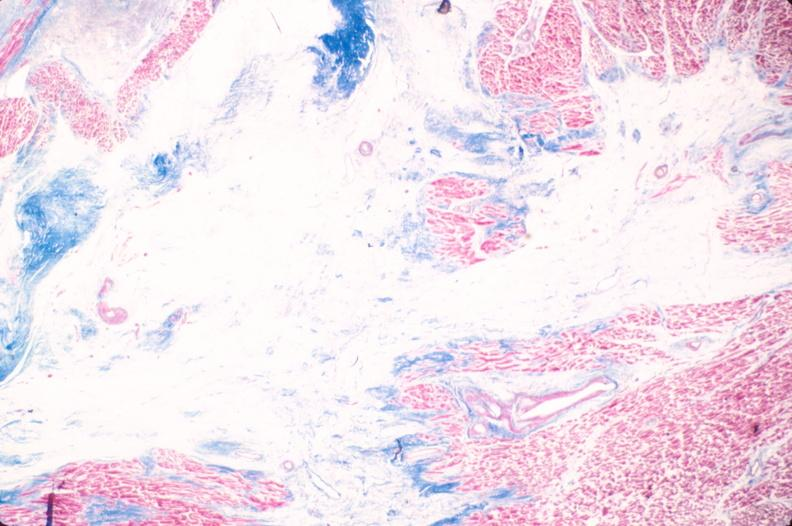how does this image show heart, old myocardial infarction?
Answer the question using a single word or phrase. With fibrosis trichrome 